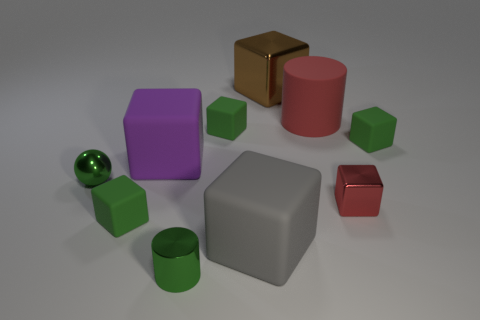There is a brown thing that is the same shape as the tiny red shiny thing; what material is it?
Provide a short and direct response. Metal. There is a brown metal block; are there any brown metal objects in front of it?
Your answer should be compact. No. Do the green cube in front of the shiny sphere and the gray thing have the same material?
Make the answer very short. Yes. Are there any big matte objects of the same color as the metal sphere?
Ensure brevity in your answer.  No. The purple thing has what shape?
Your response must be concise. Cube. What color is the large block that is left of the large gray rubber thing that is right of the small sphere?
Give a very brief answer. Purple. How big is the green rubber object that is to the right of the large brown metal block?
Your answer should be very brief. Small. Are there any other large things made of the same material as the gray thing?
Offer a very short reply. Yes. How many other brown shiny things are the same shape as the large shiny object?
Your answer should be compact. 0. What is the shape of the large matte thing in front of the green shiny object that is behind the small green metallic thing in front of the green ball?
Offer a terse response. Cube. 